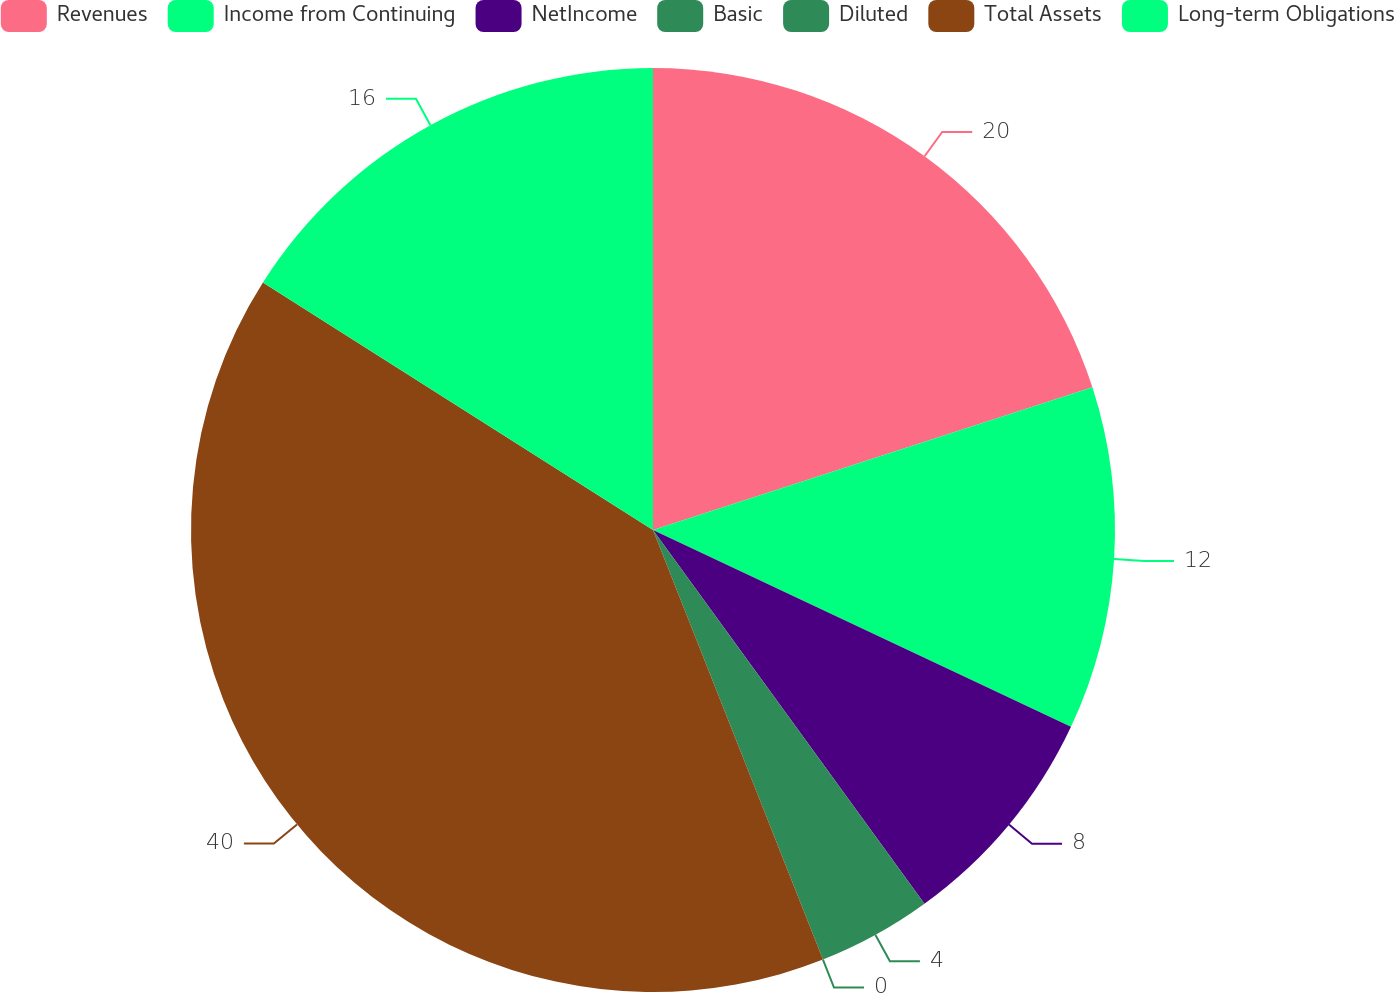<chart> <loc_0><loc_0><loc_500><loc_500><pie_chart><fcel>Revenues<fcel>Income from Continuing<fcel>NetIncome<fcel>Basic<fcel>Diluted<fcel>Total Assets<fcel>Long-term Obligations<nl><fcel>20.0%<fcel>12.0%<fcel>8.0%<fcel>4.0%<fcel>0.0%<fcel>39.99%<fcel>16.0%<nl></chart> 